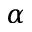Convert formula to latex. <formula><loc_0><loc_0><loc_500><loc_500>\alpha</formula> 